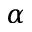Convert formula to latex. <formula><loc_0><loc_0><loc_500><loc_500>\alpha</formula> 